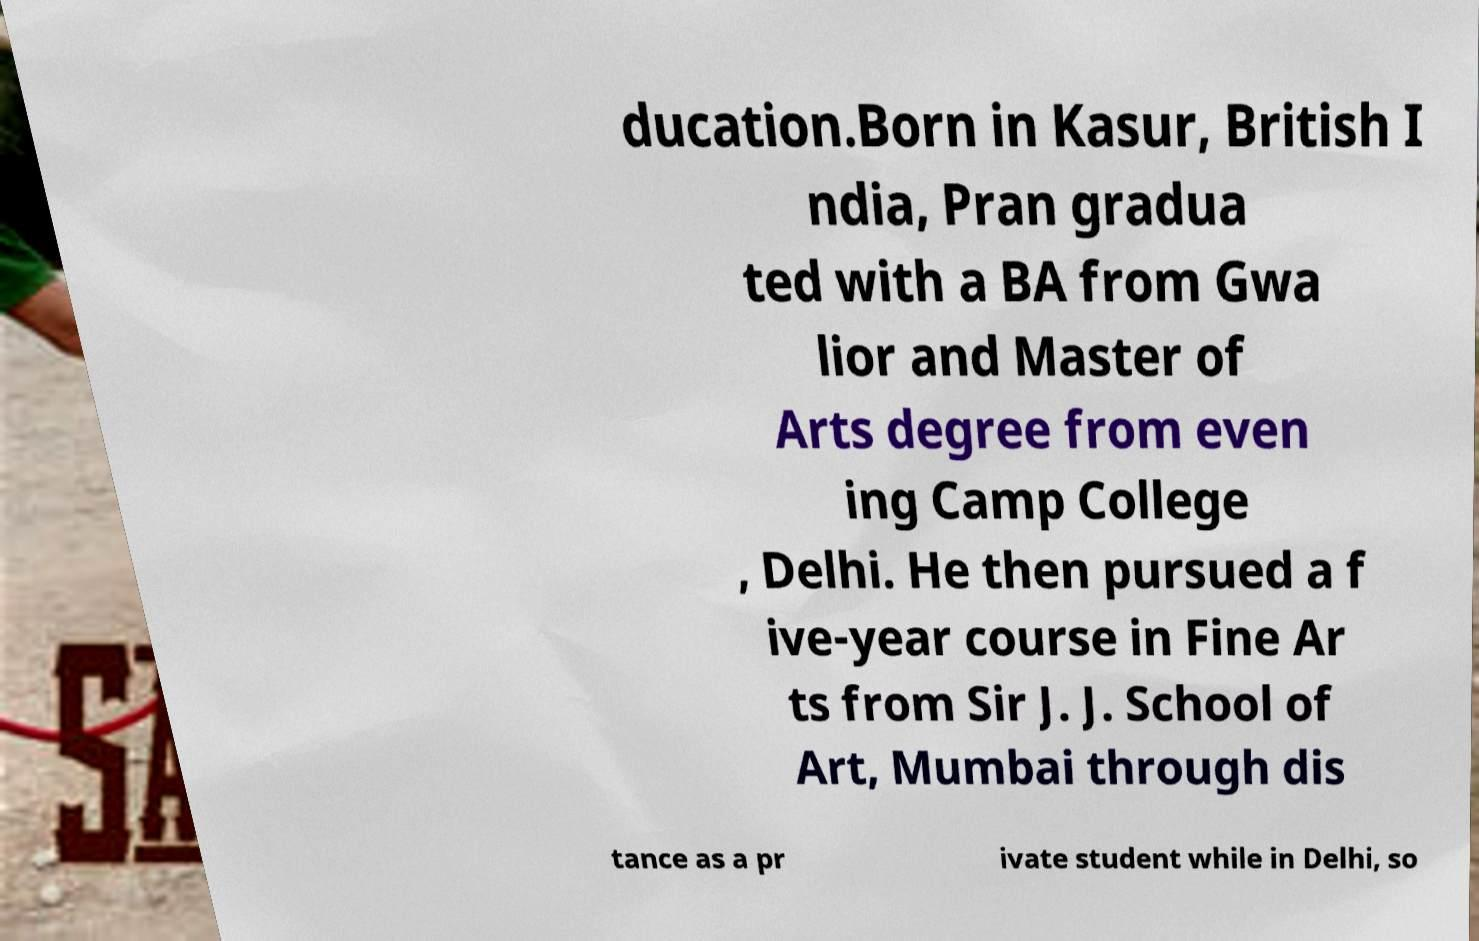I need the written content from this picture converted into text. Can you do that? ducation.Born in Kasur, British I ndia, Pran gradua ted with a BA from Gwa lior and Master of Arts degree from even ing Camp College , Delhi. He then pursued a f ive-year course in Fine Ar ts from Sir J. J. School of Art, Mumbai through dis tance as a pr ivate student while in Delhi, so 